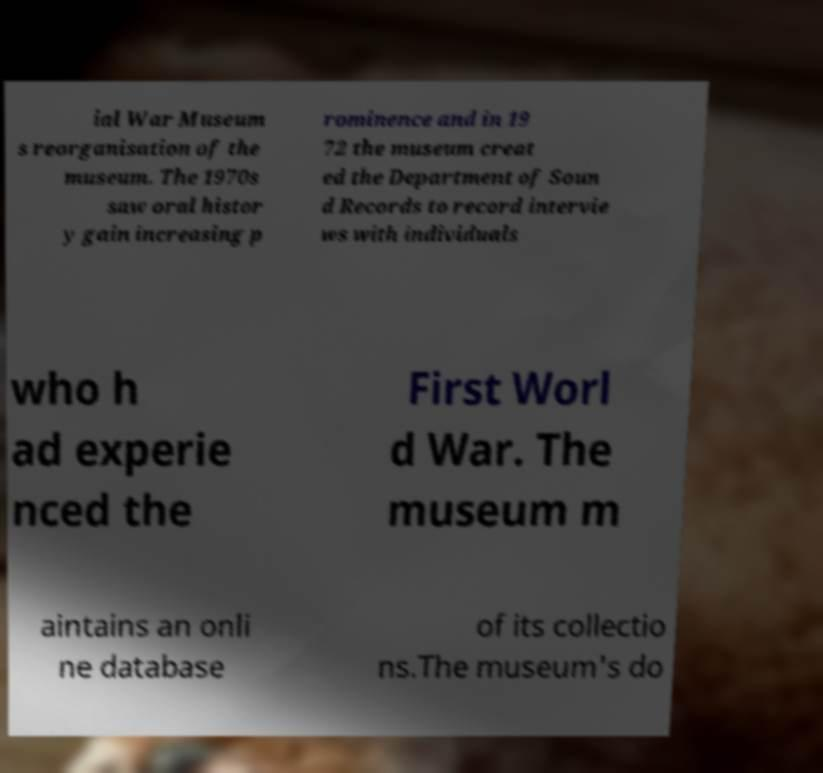Can you read and provide the text displayed in the image?This photo seems to have some interesting text. Can you extract and type it out for me? ial War Museum s reorganisation of the museum. The 1970s saw oral histor y gain increasing p rominence and in 19 72 the museum creat ed the Department of Soun d Records to record intervie ws with individuals who h ad experie nced the First Worl d War. The museum m aintains an onli ne database of its collectio ns.The museum's do 